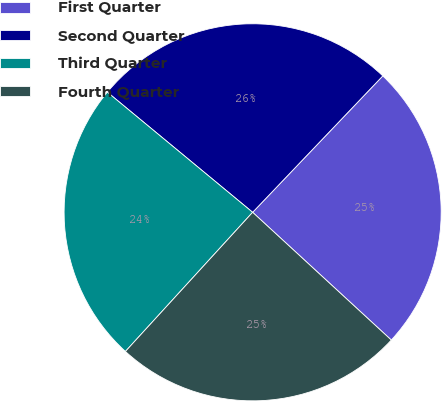Convert chart to OTSL. <chart><loc_0><loc_0><loc_500><loc_500><pie_chart><fcel>First Quarter<fcel>Second Quarter<fcel>Third Quarter<fcel>Fourth Quarter<nl><fcel>24.72%<fcel>26.13%<fcel>24.21%<fcel>24.94%<nl></chart> 